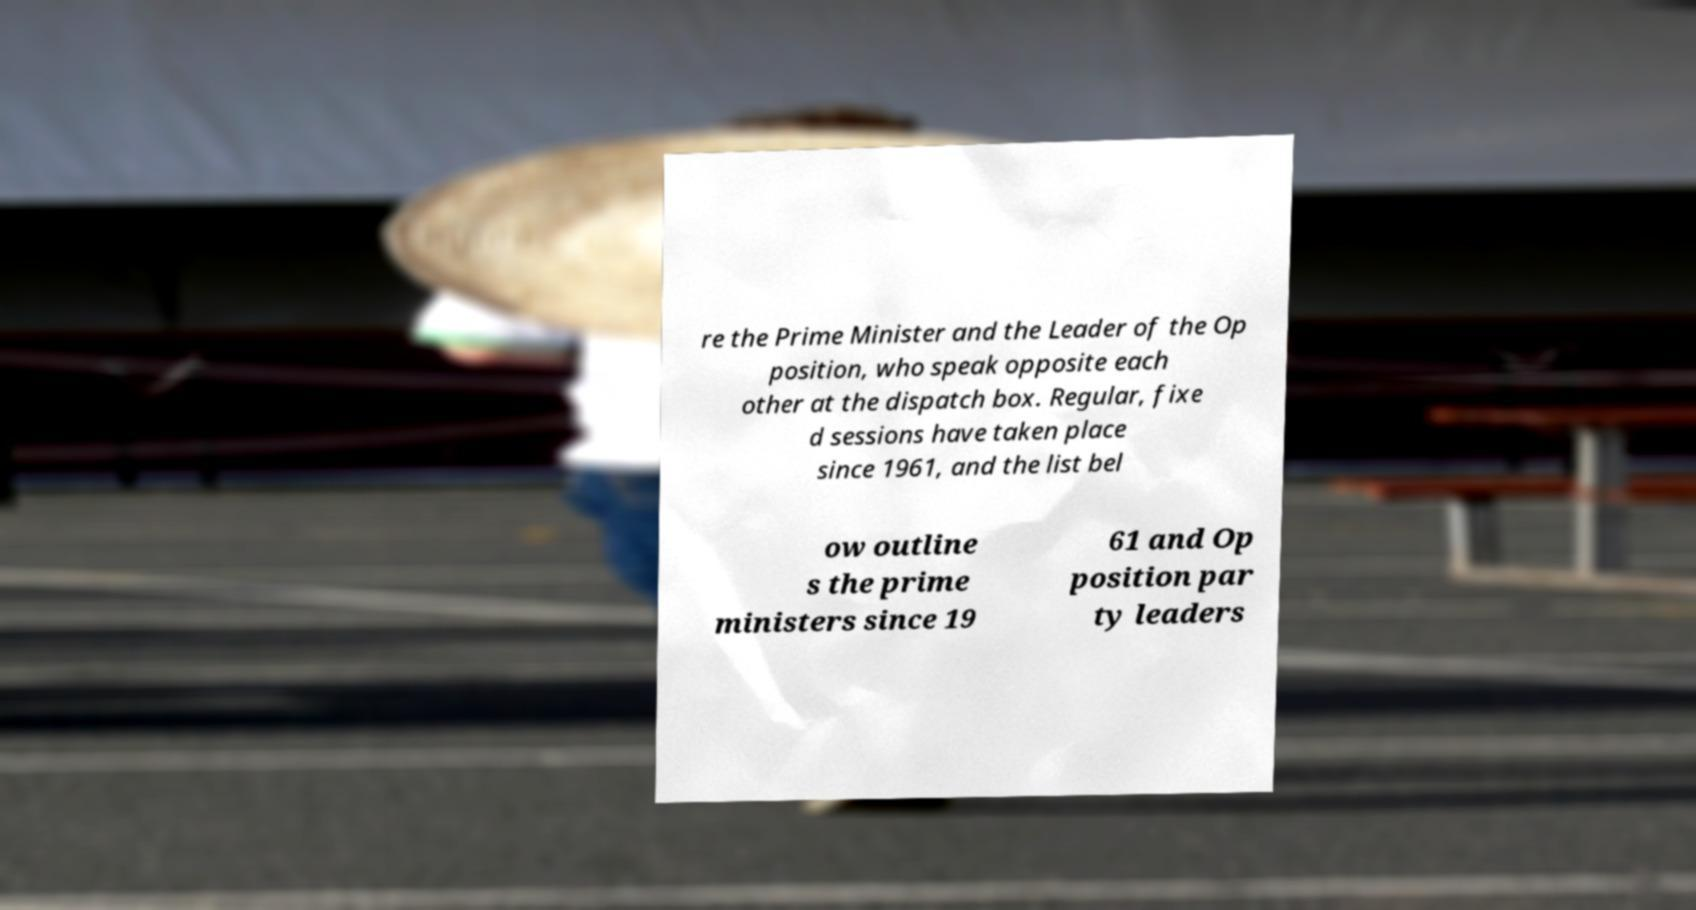Can you accurately transcribe the text from the provided image for me? re the Prime Minister and the Leader of the Op position, who speak opposite each other at the dispatch box. Regular, fixe d sessions have taken place since 1961, and the list bel ow outline s the prime ministers since 19 61 and Op position par ty leaders 